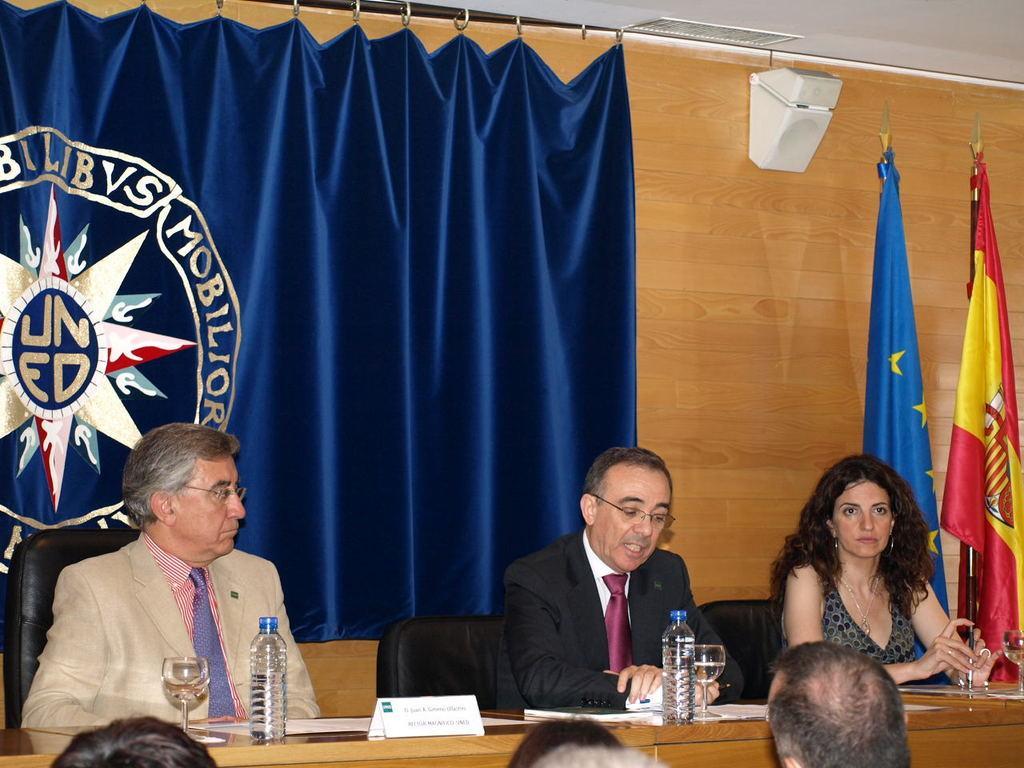Describe this image in one or two sentences. In this image we can see three people sitting. There is a table placed before them. We can see glasses, bottles, papers and a board placed on the table. At the bottom there are people. In the background there are flags, curtain and a wall. 